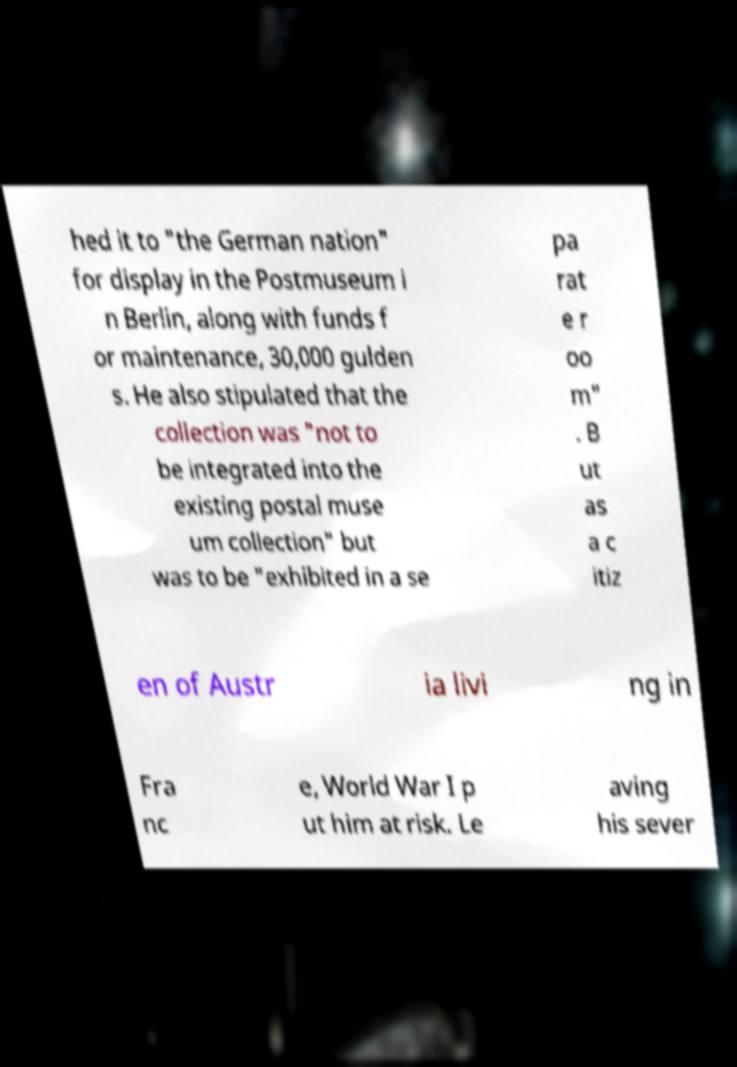There's text embedded in this image that I need extracted. Can you transcribe it verbatim? hed it to "the German nation" for display in the Postmuseum i n Berlin, along with funds f or maintenance, 30,000 gulden s. He also stipulated that the collection was "not to be integrated into the existing postal muse um collection" but was to be "exhibited in a se pa rat e r oo m" . B ut as a c itiz en of Austr ia livi ng in Fra nc e, World War I p ut him at risk. Le aving his sever 